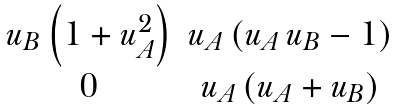<formula> <loc_0><loc_0><loc_500><loc_500>\begin{matrix} u _ { B } \left ( 1 + u _ { A } ^ { 2 } \right ) & u _ { A } \left ( u _ { A } \, u _ { B } - 1 \right ) \\ 0 & u _ { A } \left ( u _ { A } + u _ { B } \right ) \\ \end{matrix}</formula> 